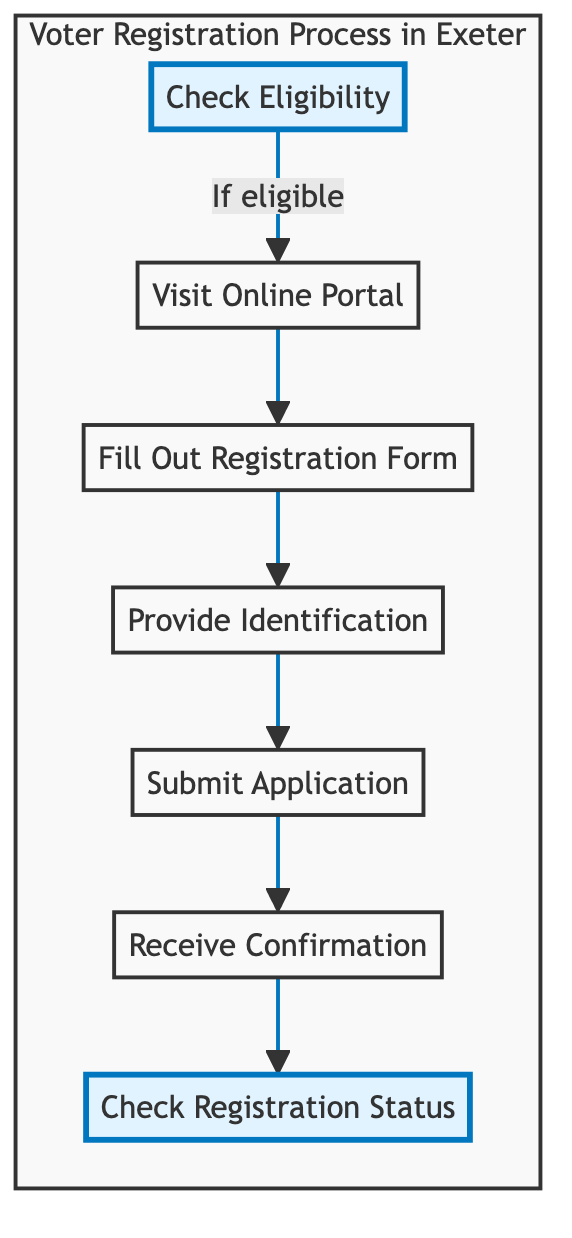What is the first step in the voter registration process? The first step, indicated in the flowchart, is "Check Eligibility." This is the starting point for the process, where individuals determine if they meet the necessary criteria to register.
Answer: Check Eligibility How many nodes are present in the diagram? By counting each distinct step in the flowchart, we can observe there are a total of 7 nodes representing different parts of the voter registration process.
Answer: 7 What document types can be uploaded during the registration process? The flowchart specifies "passport" and "driving license" as examples of necessary identification documents to be uploaded in the "Provide Identification" step.
Answer: passport, driving license What action follows the "Fill Out Registration Form" step? The diagram shows that after completing the registration form, the next action is to "Provide Identification." This indicates a sequential flow from filling out the form to ensuring identification is submitted.
Answer: Provide Identification What confirmation is received after submitting the application? After the "Submit Application" step, the flowchart indicates that one can "Receive Confirmation." This means that the applicant should check for a confirmation of their registration status.
Answer: Receive Confirmation Which two steps are highlighted in the diagram? The diagram highlights "Check Eligibility" and "Check Registration Status" to emphasize these key stages in the voter registration process, possibly indicating their importance.
Answer: Check Eligibility, Check Registration Status What is the last action to verify voter registration? The final step in the flowchart, after receiving confirmation, is to "Check Registration Status." This action indicates that voters can verify their registration online, ensuring they are prepared to vote.
Answer: Check Registration Status What is required before the "Submit Application" step? The flowchart outlines that "Provide Identification" is a requirement that must be completed before the application can be submitted, creating a necessary completion order.
Answer: Provide Identification 